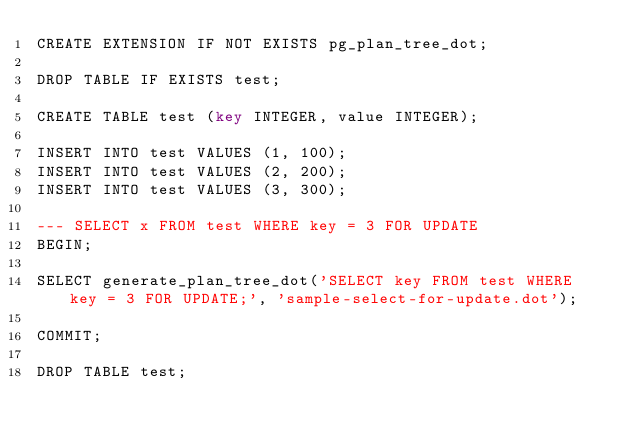Convert code to text. <code><loc_0><loc_0><loc_500><loc_500><_SQL_>CREATE EXTENSION IF NOT EXISTS pg_plan_tree_dot;

DROP TABLE IF EXISTS test;

CREATE TABLE test (key INTEGER, value INTEGER);

INSERT INTO test VALUES (1, 100);
INSERT INTO test VALUES (2, 200);
INSERT INTO test VALUES (3, 300);

--- SELECT x FROM test WHERE key = 3 FOR UPDATE
BEGIN;

SELECT generate_plan_tree_dot('SELECT key FROM test WHERE key = 3 FOR UPDATE;', 'sample-select-for-update.dot');

COMMIT;

DROP TABLE test;
</code> 